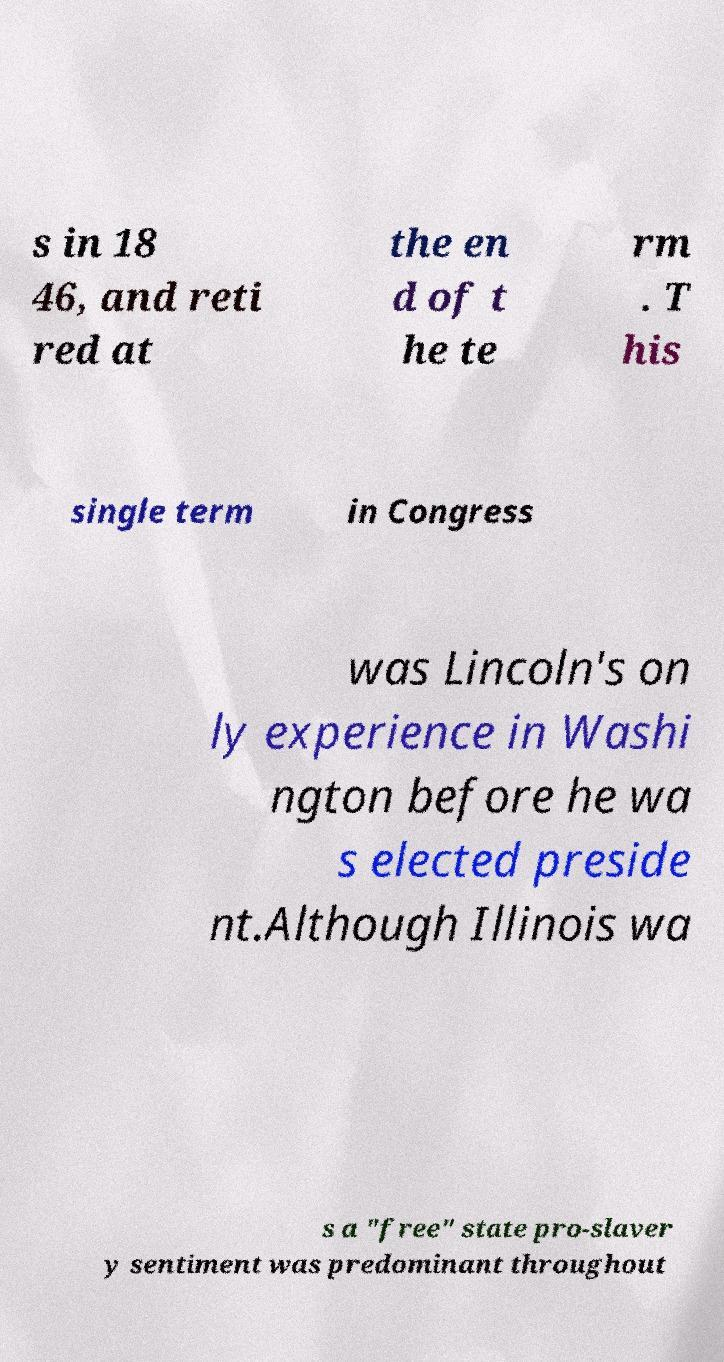I need the written content from this picture converted into text. Can you do that? s in 18 46, and reti red at the en d of t he te rm . T his single term in Congress was Lincoln's on ly experience in Washi ngton before he wa s elected preside nt.Although Illinois wa s a "free" state pro-slaver y sentiment was predominant throughout 